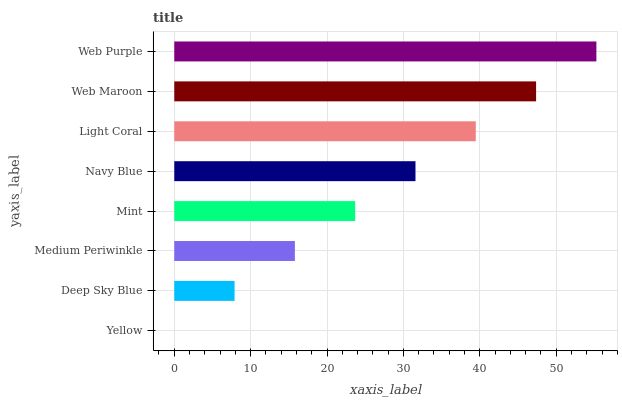Is Yellow the minimum?
Answer yes or no. Yes. Is Web Purple the maximum?
Answer yes or no. Yes. Is Deep Sky Blue the minimum?
Answer yes or no. No. Is Deep Sky Blue the maximum?
Answer yes or no. No. Is Deep Sky Blue greater than Yellow?
Answer yes or no. Yes. Is Yellow less than Deep Sky Blue?
Answer yes or no. Yes. Is Yellow greater than Deep Sky Blue?
Answer yes or no. No. Is Deep Sky Blue less than Yellow?
Answer yes or no. No. Is Navy Blue the high median?
Answer yes or no. Yes. Is Mint the low median?
Answer yes or no. Yes. Is Deep Sky Blue the high median?
Answer yes or no. No. Is Navy Blue the low median?
Answer yes or no. No. 